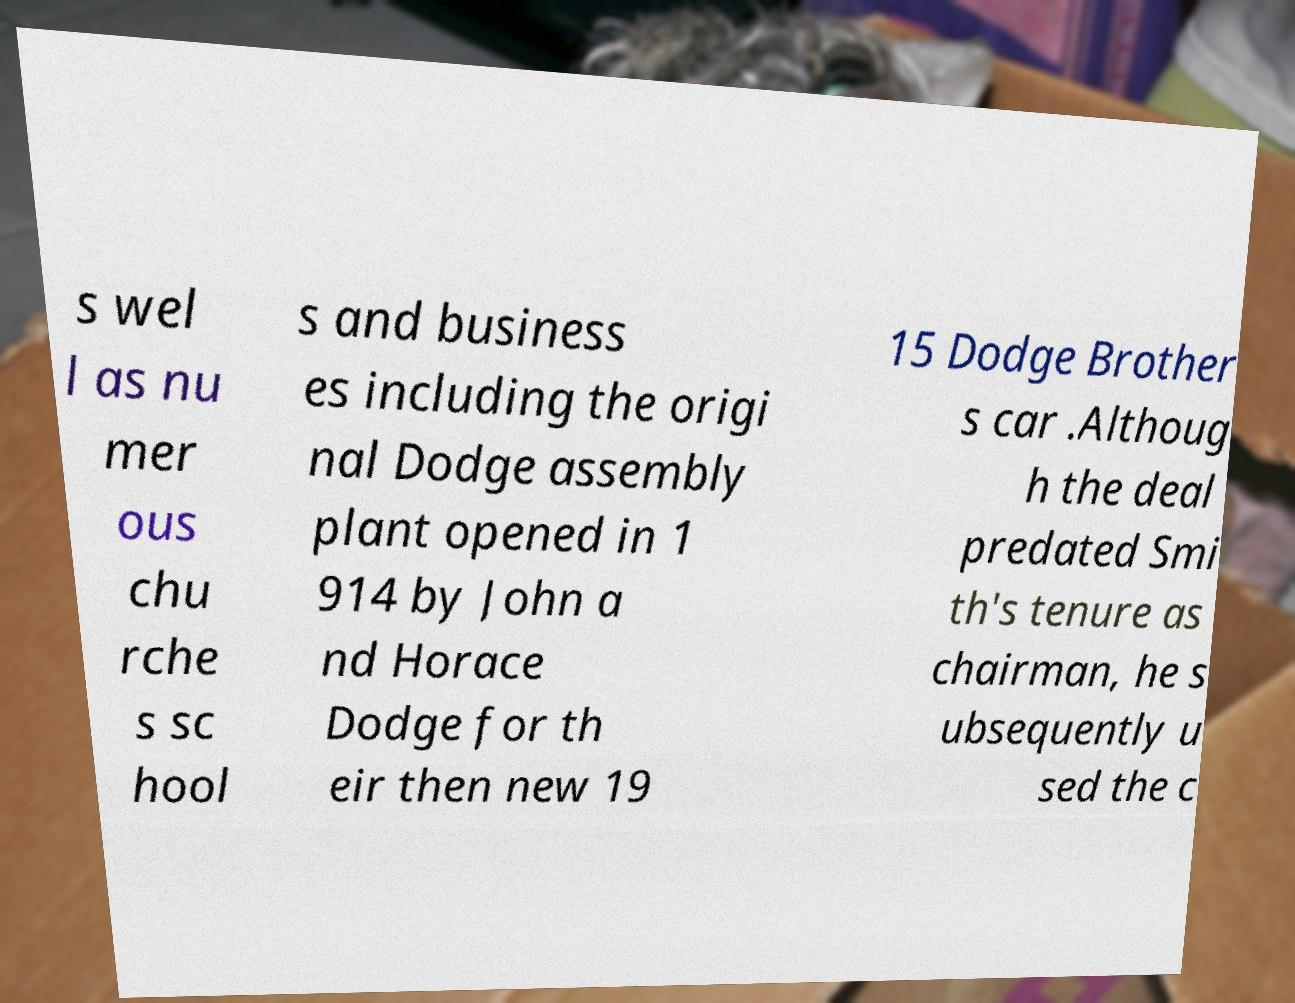There's text embedded in this image that I need extracted. Can you transcribe it verbatim? s wel l as nu mer ous chu rche s sc hool s and business es including the origi nal Dodge assembly plant opened in 1 914 by John a nd Horace Dodge for th eir then new 19 15 Dodge Brother s car .Althoug h the deal predated Smi th's tenure as chairman, he s ubsequently u sed the c 